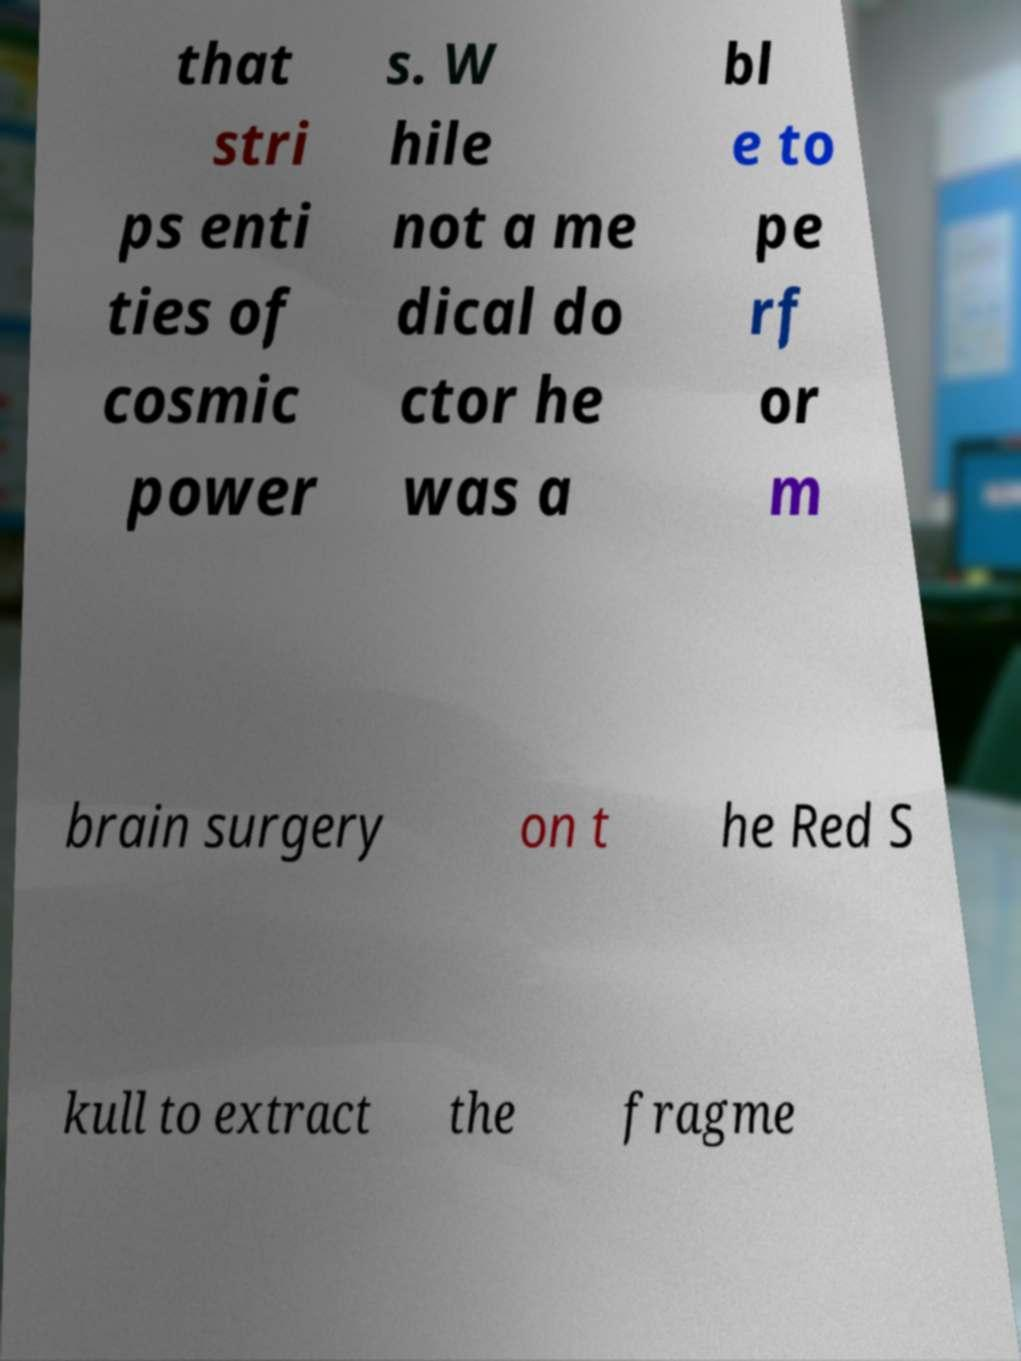Please identify and transcribe the text found in this image. that stri ps enti ties of cosmic power s. W hile not a me dical do ctor he was a bl e to pe rf or m brain surgery on t he Red S kull to extract the fragme 